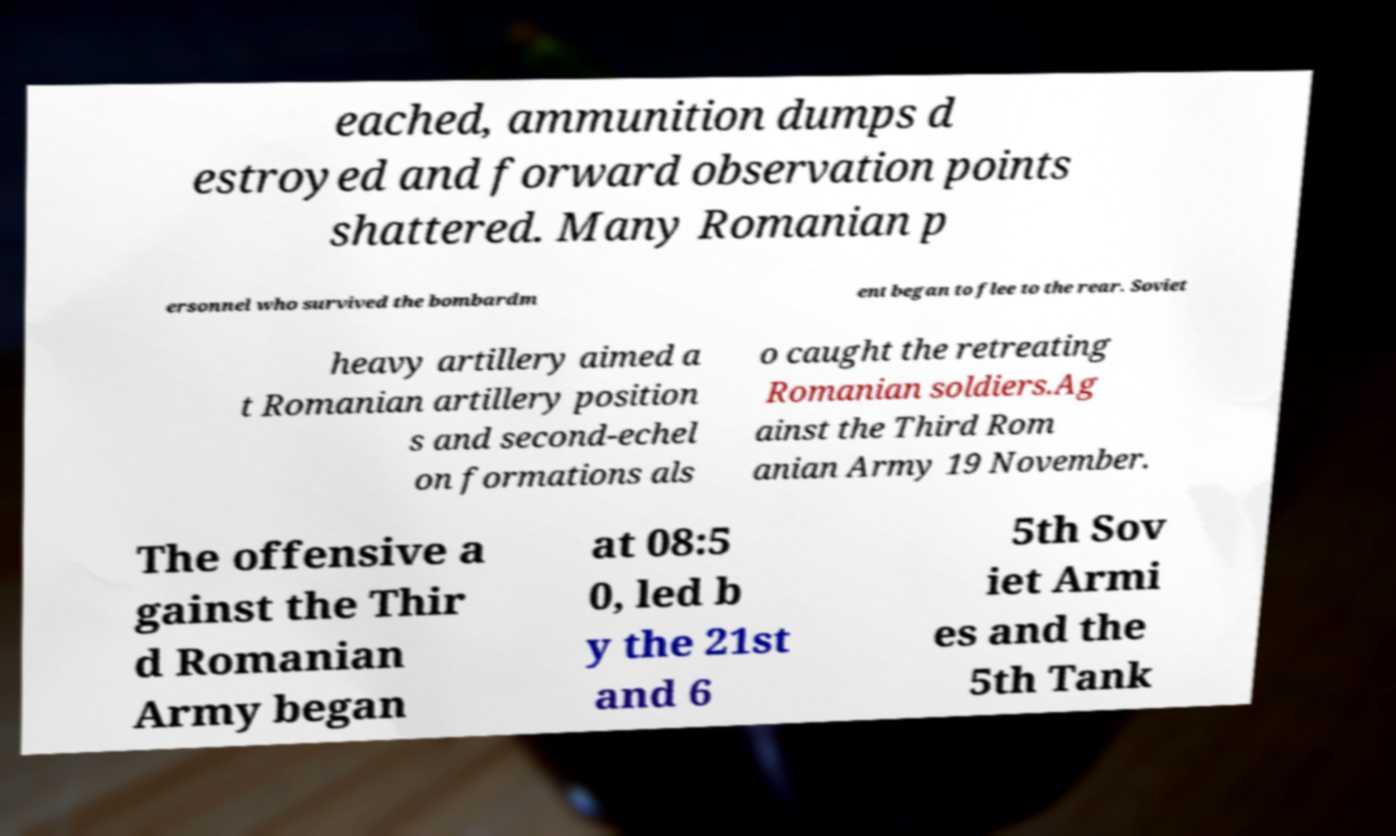Please identify and transcribe the text found in this image. eached, ammunition dumps d estroyed and forward observation points shattered. Many Romanian p ersonnel who survived the bombardm ent began to flee to the rear. Soviet heavy artillery aimed a t Romanian artillery position s and second-echel on formations als o caught the retreating Romanian soldiers.Ag ainst the Third Rom anian Army 19 November. The offensive a gainst the Thir d Romanian Army began at 08:5 0, led b y the 21st and 6 5th Sov iet Armi es and the 5th Tank 